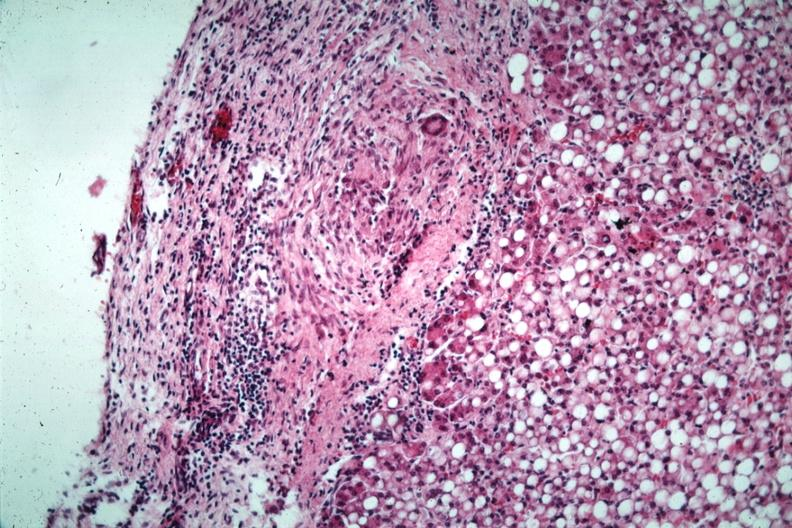how has quite good liver marked change?
Answer the question using a single word or phrase. Fatty 